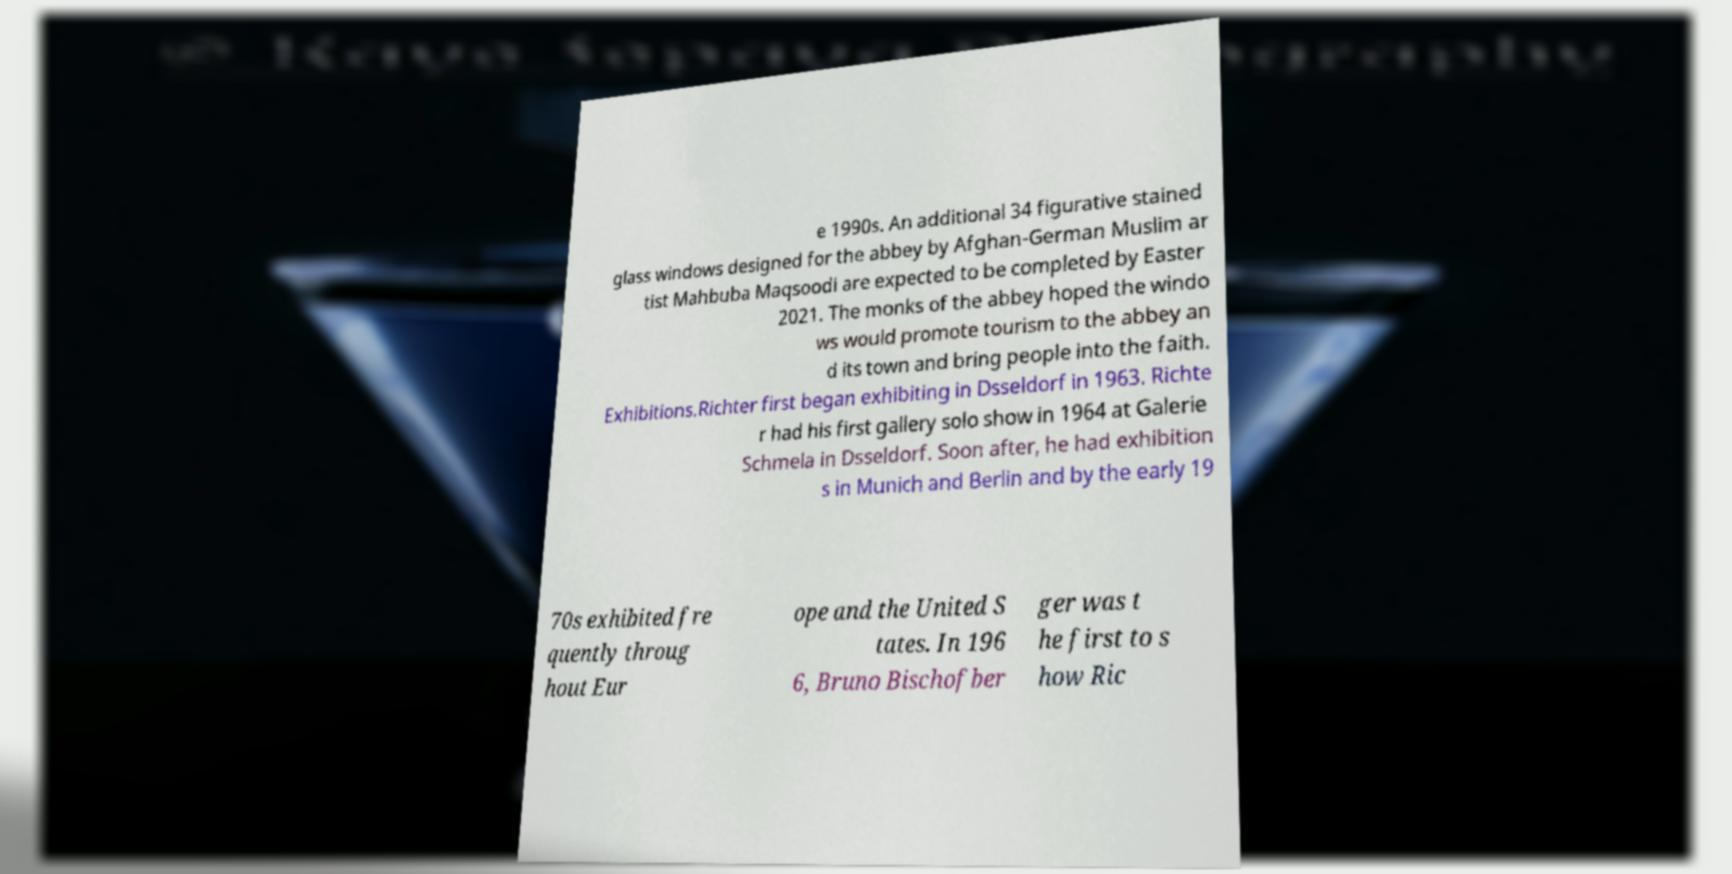There's text embedded in this image that I need extracted. Can you transcribe it verbatim? e 1990s. An additional 34 figurative stained glass windows designed for the abbey by Afghan-German Muslim ar tist Mahbuba Maqsoodi are expected to be completed by Easter 2021. The monks of the abbey hoped the windo ws would promote tourism to the abbey an d its town and bring people into the faith. Exhibitions.Richter first began exhibiting in Dsseldorf in 1963. Richte r had his first gallery solo show in 1964 at Galerie Schmela in Dsseldorf. Soon after, he had exhibition s in Munich and Berlin and by the early 19 70s exhibited fre quently throug hout Eur ope and the United S tates. In 196 6, Bruno Bischofber ger was t he first to s how Ric 